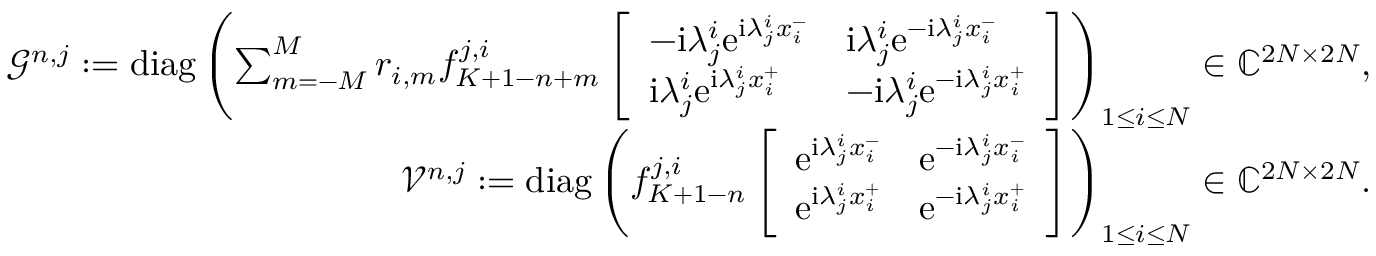<formula> <loc_0><loc_0><loc_500><loc_500>\begin{array} { r } { \mathcal { G } ^ { n , j } \colon = d i a g \left ( \sum _ { m = - M } ^ { M } r _ { i , m } f _ { K + 1 - n + m } ^ { j , i } \left [ \begin{array} { l l } { - i \lambda _ { j } ^ { i } e ^ { i \lambda _ { j } ^ { i } x _ { i } ^ { - } } } & { i \lambda _ { j } ^ { i } e ^ { - i \lambda _ { j } ^ { i } x _ { i } ^ { - } } } \\ { i \lambda _ { j } ^ { i } e ^ { i \lambda _ { j } ^ { i } x _ { i } ^ { + } } } & { - i \lambda _ { j } ^ { i } e ^ { - i \lambda _ { j } ^ { i } x _ { i } ^ { + } } } \end{array} \right ] \right ) _ { 1 \leq i \leq N } \in \mathbb { C } ^ { 2 N \times 2 N } , } \\ { \mathcal { V } ^ { n , j } \colon = d i a g \left ( f _ { K + 1 - n } ^ { j , i } \left [ \begin{array} { l l } { e ^ { i \lambda _ { j } ^ { i } x _ { i } ^ { - } } } & { e ^ { - i \lambda _ { j } ^ { i } x _ { i } ^ { - } } } \\ { e ^ { i \lambda _ { j } ^ { i } x _ { i } ^ { + } } } & { e ^ { - i \lambda _ { j } ^ { i } x _ { i } ^ { + } } } \end{array} \right ] \right ) _ { 1 \leq i \leq N } \in \mathbb { C } ^ { 2 N \times 2 N } . } \end{array}</formula> 